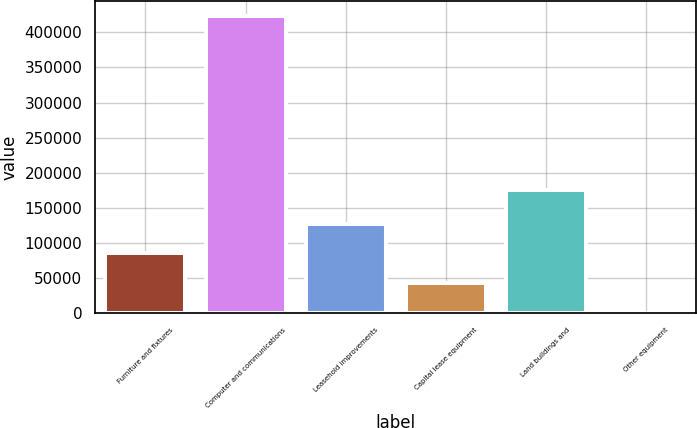Convert chart. <chart><loc_0><loc_0><loc_500><loc_500><bar_chart><fcel>Furniture and fixtures<fcel>Computer and communications<fcel>Leasehold improvements<fcel>Capital lease equipment<fcel>Land buildings and<fcel>Other equipment<nl><fcel>85329.6<fcel>422716<fcel>127503<fcel>43156.3<fcel>176216<fcel>983<nl></chart> 